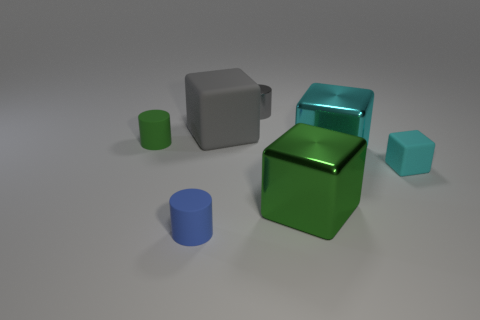There is a shiny thing that is the same color as the tiny block; what is its size?
Your answer should be compact. Large. There is a tiny metal object that is the same color as the big matte cube; what is its shape?
Give a very brief answer. Cylinder. Does the big cyan thing have the same material as the tiny gray cylinder?
Your answer should be compact. Yes. What number of small objects are behind the tiny rubber thing that is right of the big cube behind the tiny green cylinder?
Your answer should be compact. 2. What is the shape of the green object that is to the right of the blue rubber thing?
Give a very brief answer. Cube. How many other objects are the same material as the tiny cyan block?
Your response must be concise. 3. Is the color of the tiny rubber block the same as the metallic cylinder?
Your answer should be compact. No. Are there fewer small gray objects in front of the metal cylinder than big gray blocks on the left side of the green cylinder?
Give a very brief answer. No. There is a large matte thing that is the same shape as the big green shiny object; what color is it?
Make the answer very short. Gray. There is a matte thing that is left of the blue rubber cylinder; is its size the same as the gray cube?
Provide a short and direct response. No. 